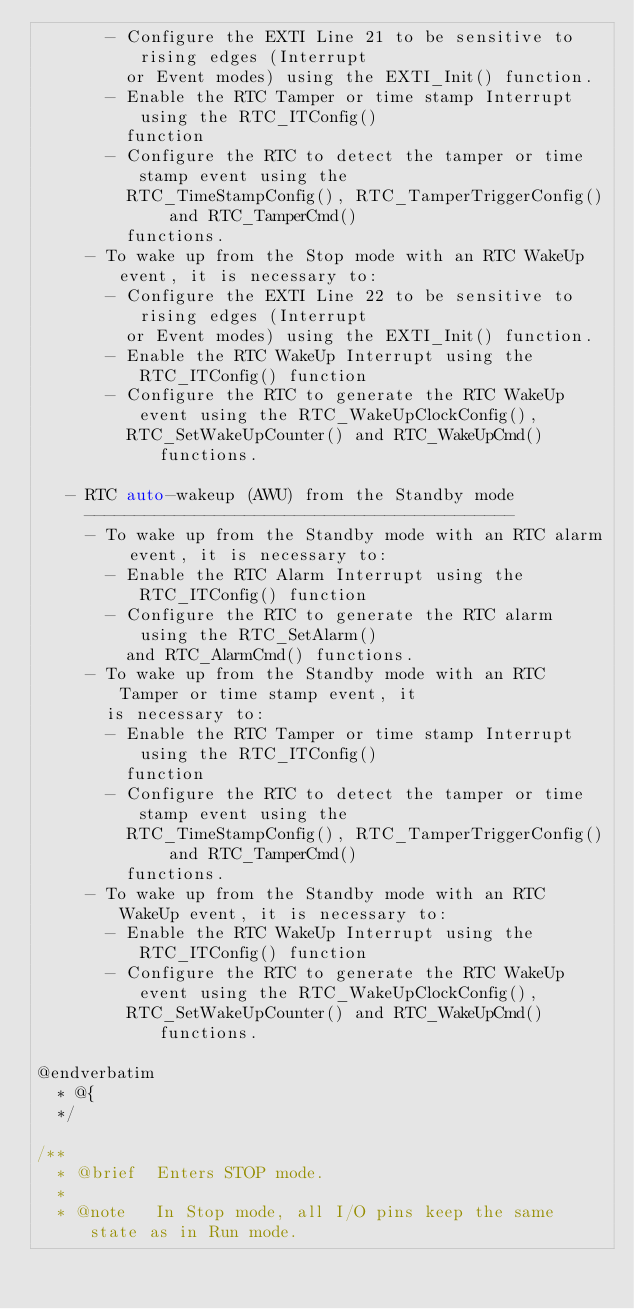<code> <loc_0><loc_0><loc_500><loc_500><_C_>       - Configure the EXTI Line 21 to be sensitive to rising edges (Interrupt
         or Event modes) using the EXTI_Init() function.
       - Enable the RTC Tamper or time stamp Interrupt using the RTC_ITConfig()
         function
       - Configure the RTC to detect the tamper or time stamp event using the
         RTC_TimeStampConfig(), RTC_TamperTriggerConfig() and RTC_TamperCmd()
         functions.
     - To wake up from the Stop mode with an RTC WakeUp event, it is necessary to:
       - Configure the EXTI Line 22 to be sensitive to rising edges (Interrupt
         or Event modes) using the EXTI_Init() function.
       - Enable the RTC WakeUp Interrupt using the RTC_ITConfig() function
       - Configure the RTC to generate the RTC WakeUp event using the RTC_WakeUpClockConfig(),
         RTC_SetWakeUpCounter() and RTC_WakeUpCmd() functions.

   - RTC auto-wakeup (AWU) from the Standby mode
     -------------------------------------------
     - To wake up from the Standby mode with an RTC alarm event, it is necessary to:
       - Enable the RTC Alarm Interrupt using the RTC_ITConfig() function
       - Configure the RTC to generate the RTC alarm using the RTC_SetAlarm()
         and RTC_AlarmCmd() functions.
     - To wake up from the Standby mode with an RTC Tamper or time stamp event, it
       is necessary to:
       - Enable the RTC Tamper or time stamp Interrupt using the RTC_ITConfig()
         function
       - Configure the RTC to detect the tamper or time stamp event using the
         RTC_TimeStampConfig(), RTC_TamperTriggerConfig() and RTC_TamperCmd()
         functions.
     - To wake up from the Standby mode with an RTC WakeUp event, it is necessary to:
       - Enable the RTC WakeUp Interrupt using the RTC_ITConfig() function
       - Configure the RTC to generate the RTC WakeUp event using the RTC_WakeUpClockConfig(),
         RTC_SetWakeUpCounter() and RTC_WakeUpCmd() functions.

@endverbatim
  * @{
  */

/**
  * @brief  Enters STOP mode.
  *
  * @note   In Stop mode, all I/O pins keep the same state as in Run mode.</code> 